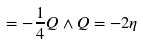<formula> <loc_0><loc_0><loc_500><loc_500>= - \frac { 1 } { 4 } Q \wedge Q = - 2 \eta</formula> 